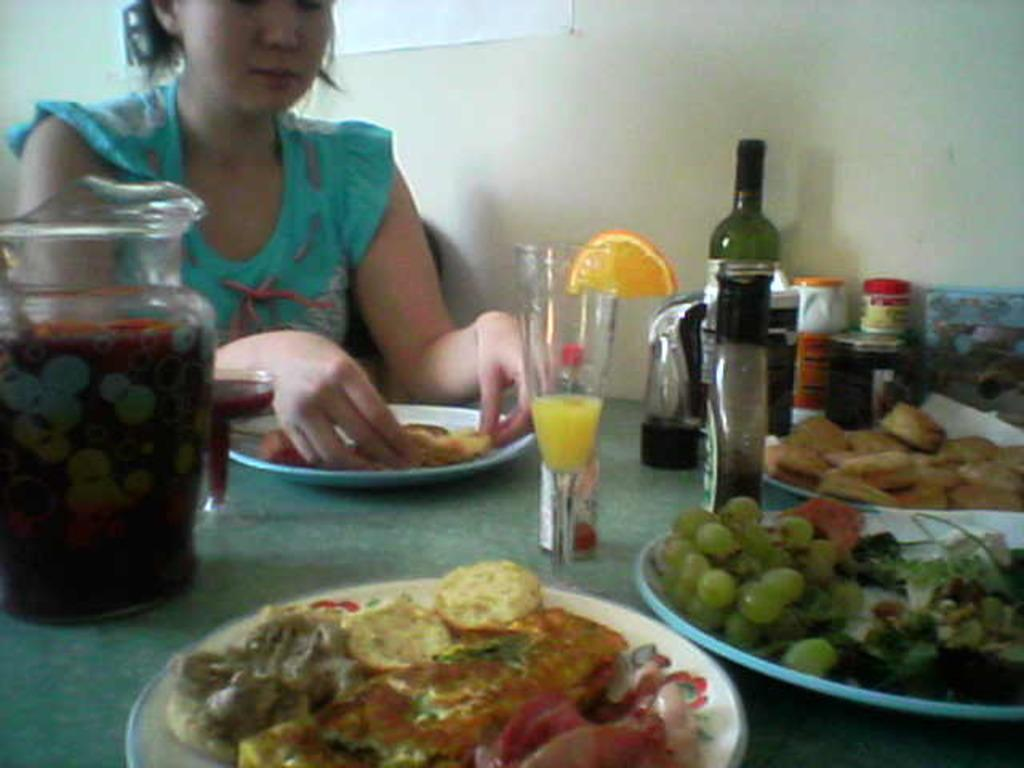What is the woman doing in the image? The woman is sitting on a chair in the image. What objects can be seen on the table or nearby the woman? There is a jar, a glass, a bottle, a box, and a plate with food and grapes in the image. Is the woman driving a car in the image? No, the woman is sitting on a chair, and there is no car or driving activity depicted in the image. 